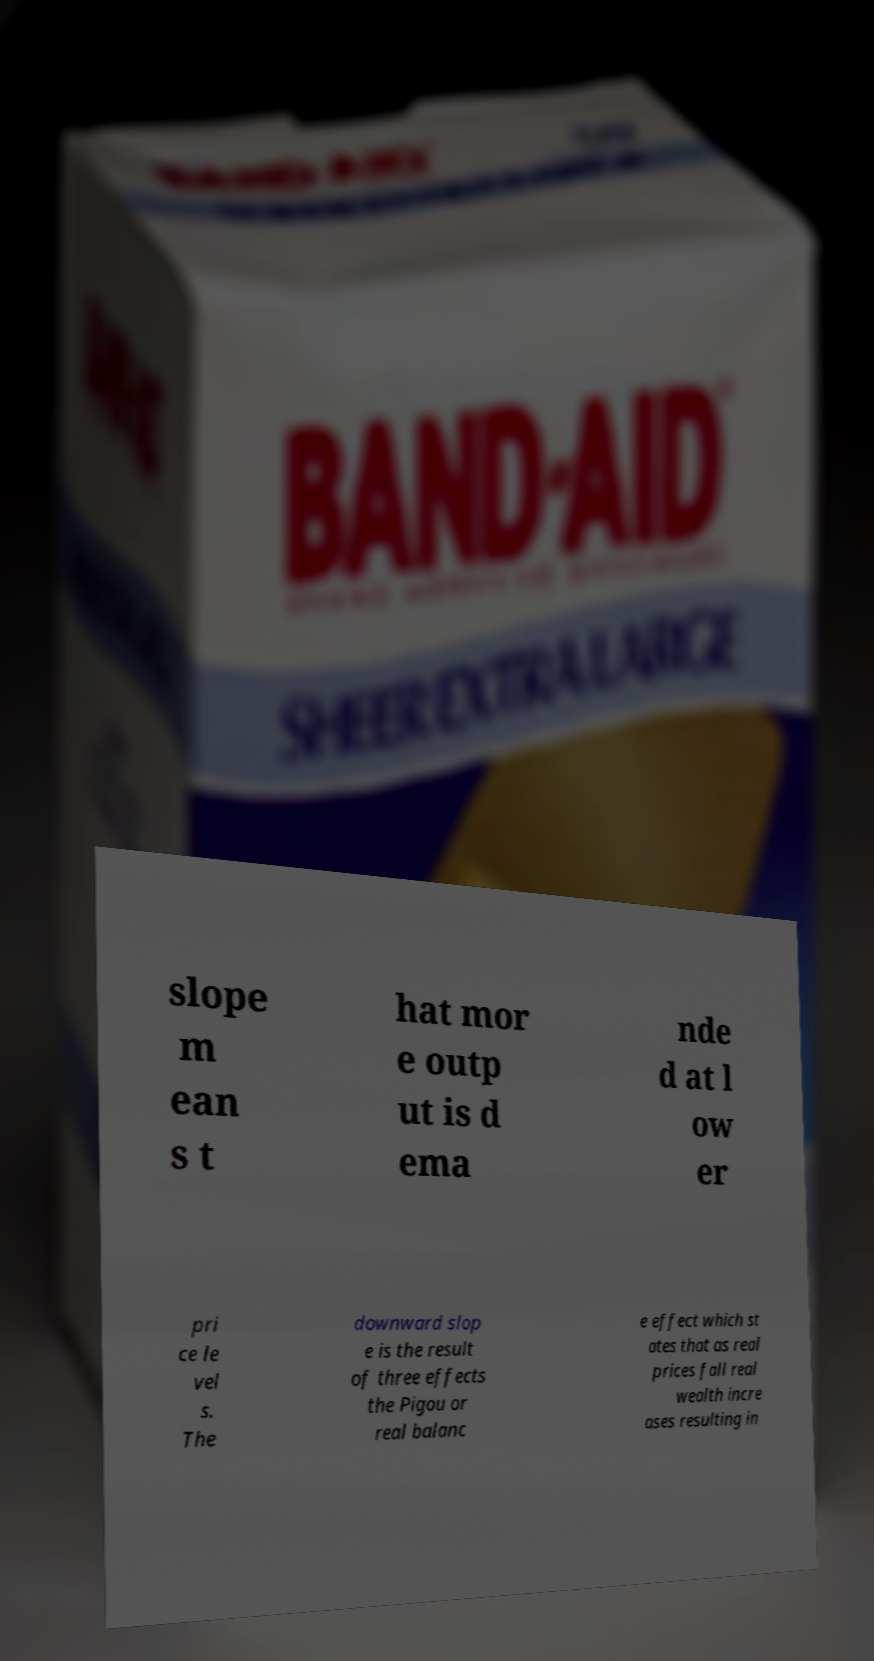What messages or text are displayed in this image? I need them in a readable, typed format. slope m ean s t hat mor e outp ut is d ema nde d at l ow er pri ce le vel s. The downward slop e is the result of three effects the Pigou or real balanc e effect which st ates that as real prices fall real wealth incre ases resulting in 